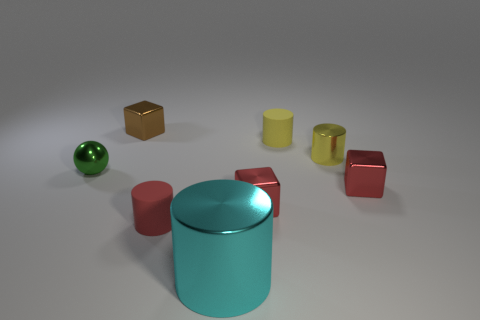There is another cylinder that is the same color as the tiny metallic cylinder; what is it made of?
Give a very brief answer. Rubber. The metallic ball has what color?
Give a very brief answer. Green. What is the color of the tiny cylinder in front of the small thing on the left side of the tiny shiny block that is to the left of the small red rubber object?
Your answer should be very brief. Red. Is the shape of the big thing the same as the small object left of the small brown metal block?
Keep it short and to the point. No. There is a small thing that is to the left of the cyan metallic cylinder and in front of the metallic sphere; what is its color?
Your answer should be very brief. Red. Is there a green metallic thing of the same shape as the large cyan object?
Provide a succinct answer. No. Does the ball have the same color as the big metal cylinder?
Offer a terse response. No. There is a cyan object in front of the yellow rubber cylinder; is there a red rubber cylinder that is in front of it?
Provide a short and direct response. No. What number of things are objects on the right side of the big metallic thing or tiny objects that are to the left of the red rubber object?
Make the answer very short. 6. How many things are small red objects or tiny metallic objects that are right of the tiny brown block?
Your answer should be very brief. 4. 